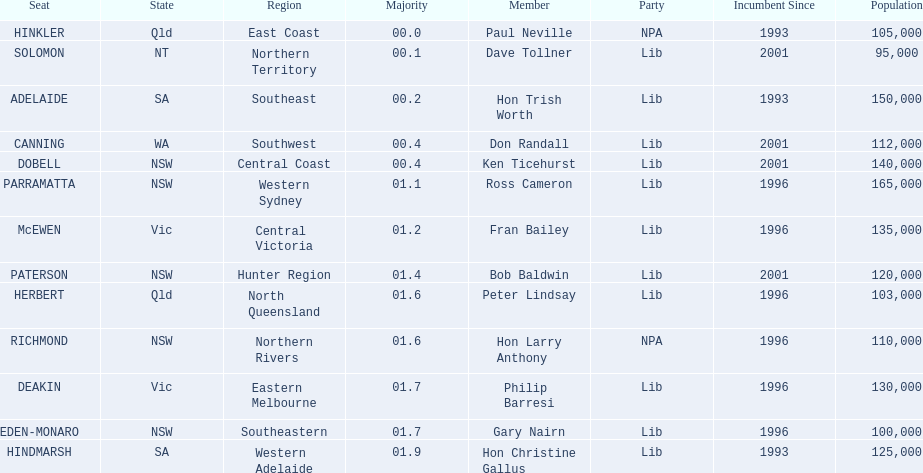What was the total majority that the dobell seat had? 00.4. 